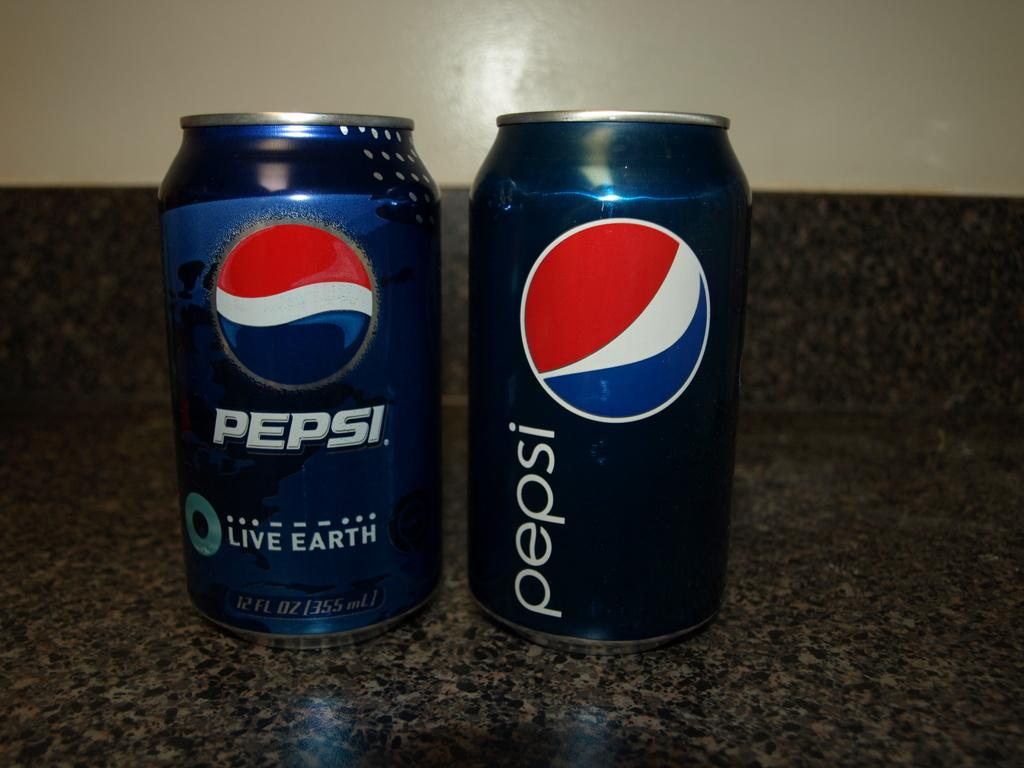<image>
Describe the image concisely. two cans of Pepsi on a marbled surface 